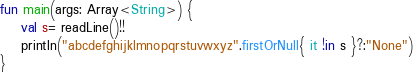<code> <loc_0><loc_0><loc_500><loc_500><_Kotlin_>fun main(args: Array<String>) {
    val s= readLine()!!
    println("abcdefghijklmnopqrstuvwxyz".firstOrNull{ it !in s }?:"None")
}

</code> 